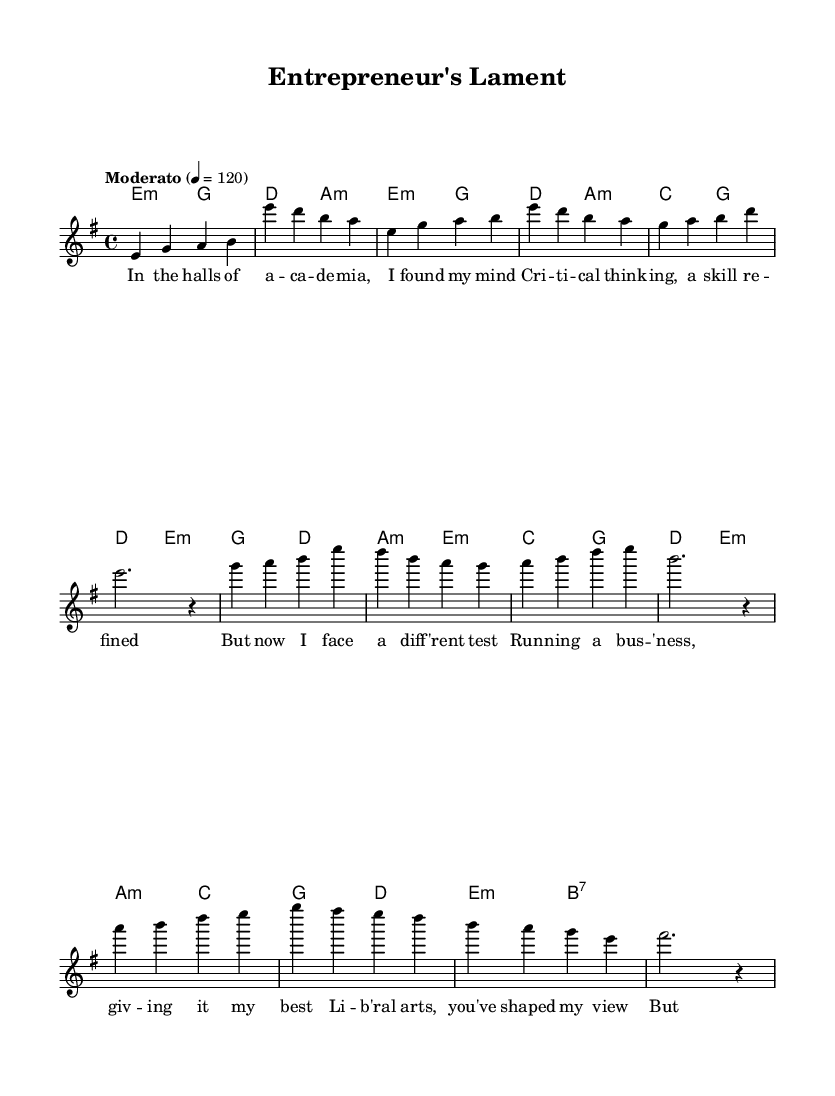What is the key signature of this music? The key signature is E minor, which contains one sharp (F#). This is indicated at the beginning of the score.
Answer: E minor What is the time signature of this music? The time signature is 4/4, which means there are four beats in a measure and the quarter note receives one beat. This can be seen at the beginning of the score as well.
Answer: 4/4 What is the tempo marking of this piece? The tempo marking is "Moderato," which implies a moderate speed of performance at 120 beats per minute. This is specified in the tempo indication at the beginning of the score.
Answer: Moderato How many measures are in the verse section? The verse section consists of 4 measures (as counted from the melody and lyrics for the verse). Each measure is clearly delineated with vertical lines in the musical notation.
Answer: 4 Which section of the song has lyrics that start with "In the halls"? The lyrics that begin with "In the halls of a -- ca -- de -- mia" belong to the verse section. The answer can be found by looking at where these lyrics are placed relative to the melody notation.
Answer: Verse What type of chords are primarily used in the chorus? The chords primarily used in the chorus are minor chords (indicated by "m" next to the chords in the chord mode). This is observed from the chord symbols above the melody in the chorus section.
Answer: Minor 